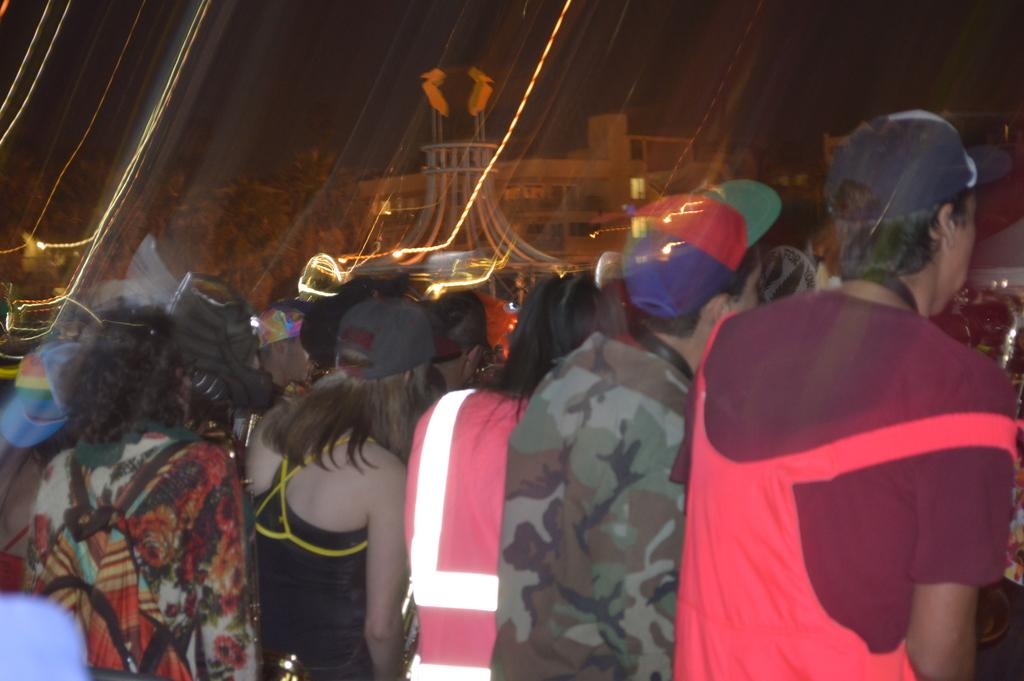What is the main subject of the image? The main subject of the image is a crowd. Can you describe any specific details about the people in the crowd? Some people in the crowd are wearing caps. What can be seen in the background of the image? There are lights and at least one building in the background of the image. Are there any other items visible in the image besides the crowd and the background? Yes, there are other unspecified items in the image. What type of lace can be seen growing out of the building in the image? There is no lace visible in the image, nor is there any indication of growth or a connection between the building and lace. 